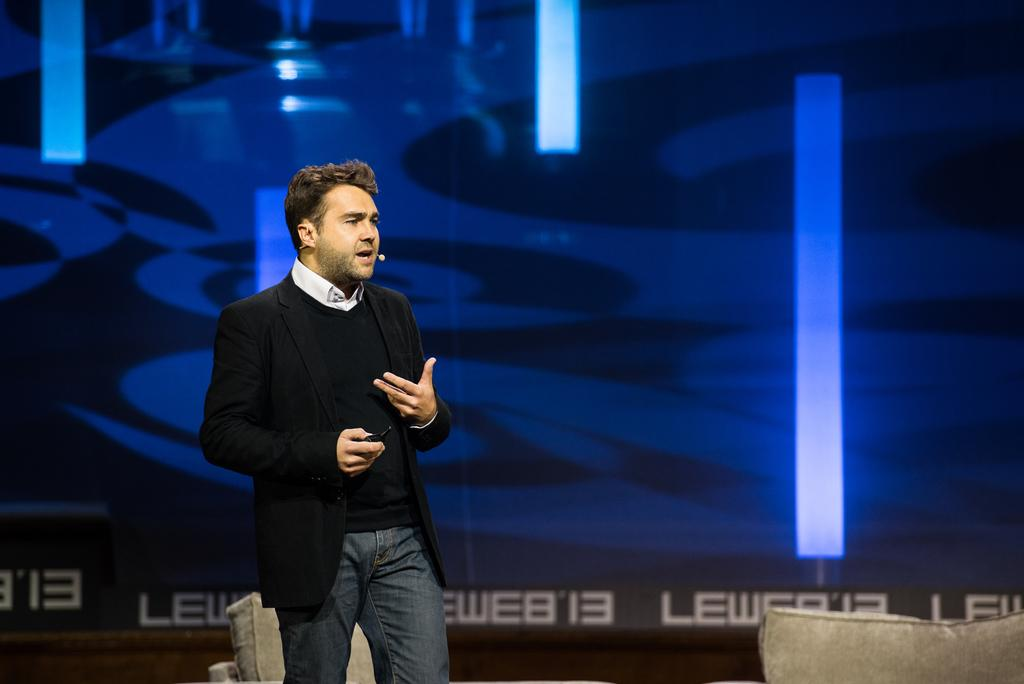Who is present in the image? There is a man in the image. What can be seen behind the man? The man is standing in front of a blue background. What is the man doing in the image? The man is looking at someone. What is the man's father doing in the image? There is no information about the man's father in the image, and therefore no such activity can be observed. 